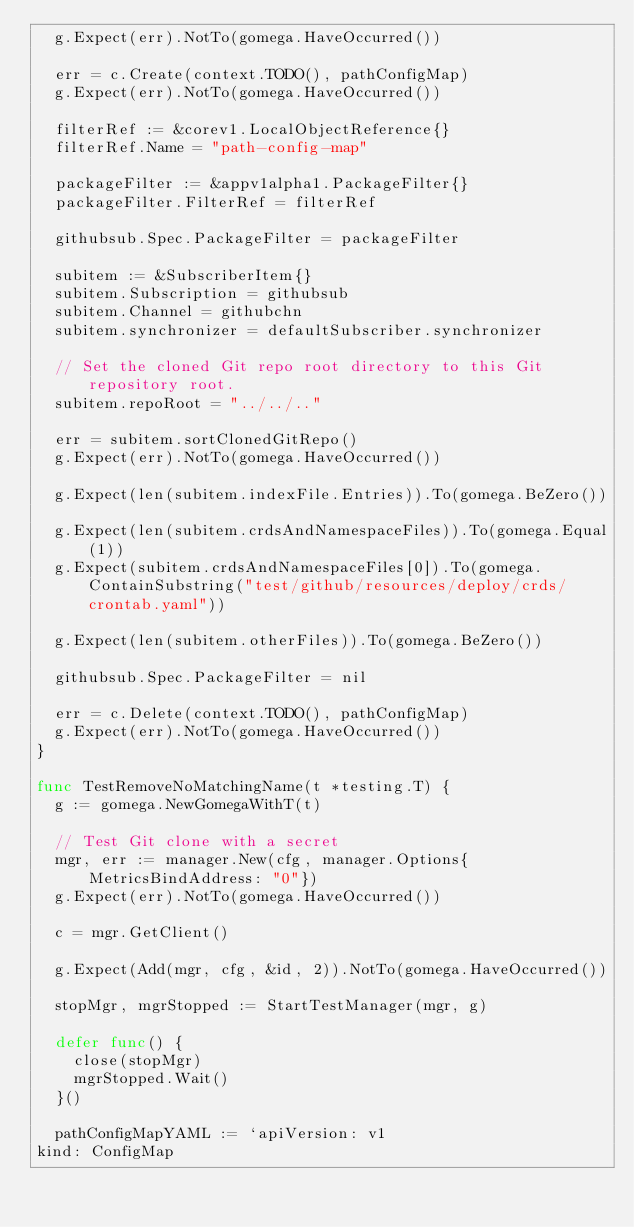Convert code to text. <code><loc_0><loc_0><loc_500><loc_500><_Go_>	g.Expect(err).NotTo(gomega.HaveOccurred())

	err = c.Create(context.TODO(), pathConfigMap)
	g.Expect(err).NotTo(gomega.HaveOccurred())

	filterRef := &corev1.LocalObjectReference{}
	filterRef.Name = "path-config-map"

	packageFilter := &appv1alpha1.PackageFilter{}
	packageFilter.FilterRef = filterRef

	githubsub.Spec.PackageFilter = packageFilter

	subitem := &SubscriberItem{}
	subitem.Subscription = githubsub
	subitem.Channel = githubchn
	subitem.synchronizer = defaultSubscriber.synchronizer

	// Set the cloned Git repo root directory to this Git repository root.
	subitem.repoRoot = "../../.."

	err = subitem.sortClonedGitRepo()
	g.Expect(err).NotTo(gomega.HaveOccurred())

	g.Expect(len(subitem.indexFile.Entries)).To(gomega.BeZero())

	g.Expect(len(subitem.crdsAndNamespaceFiles)).To(gomega.Equal(1))
	g.Expect(subitem.crdsAndNamespaceFiles[0]).To(gomega.ContainSubstring("test/github/resources/deploy/crds/crontab.yaml"))

	g.Expect(len(subitem.otherFiles)).To(gomega.BeZero())

	githubsub.Spec.PackageFilter = nil

	err = c.Delete(context.TODO(), pathConfigMap)
	g.Expect(err).NotTo(gomega.HaveOccurred())
}

func TestRemoveNoMatchingName(t *testing.T) {
	g := gomega.NewGomegaWithT(t)

	// Test Git clone with a secret
	mgr, err := manager.New(cfg, manager.Options{MetricsBindAddress: "0"})
	g.Expect(err).NotTo(gomega.HaveOccurred())

	c = mgr.GetClient()

	g.Expect(Add(mgr, cfg, &id, 2)).NotTo(gomega.HaveOccurred())

	stopMgr, mgrStopped := StartTestManager(mgr, g)

	defer func() {
		close(stopMgr)
		mgrStopped.Wait()
	}()

	pathConfigMapYAML := `apiVersion: v1
kind: ConfigMap</code> 